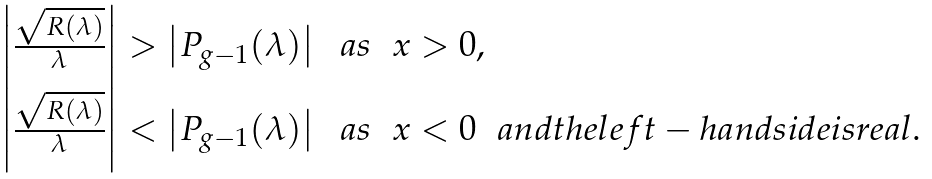<formula> <loc_0><loc_0><loc_500><loc_500>\begin{array} { l } \left | \frac { \sqrt { R ( \lambda ) } } { \lambda } \right | > \left | P _ { g - 1 } ( \lambda ) \right | \ \ a s \ \ x > 0 , \\ \left | \frac { \sqrt { R ( \lambda ) } } { \lambda } \right | < \left | P _ { g - 1 } ( \lambda ) \right | \ \ a s \ \ x < 0 \ \ a n d t h e l e f t - h a n d s i d e i s r e a l . \end{array}</formula> 